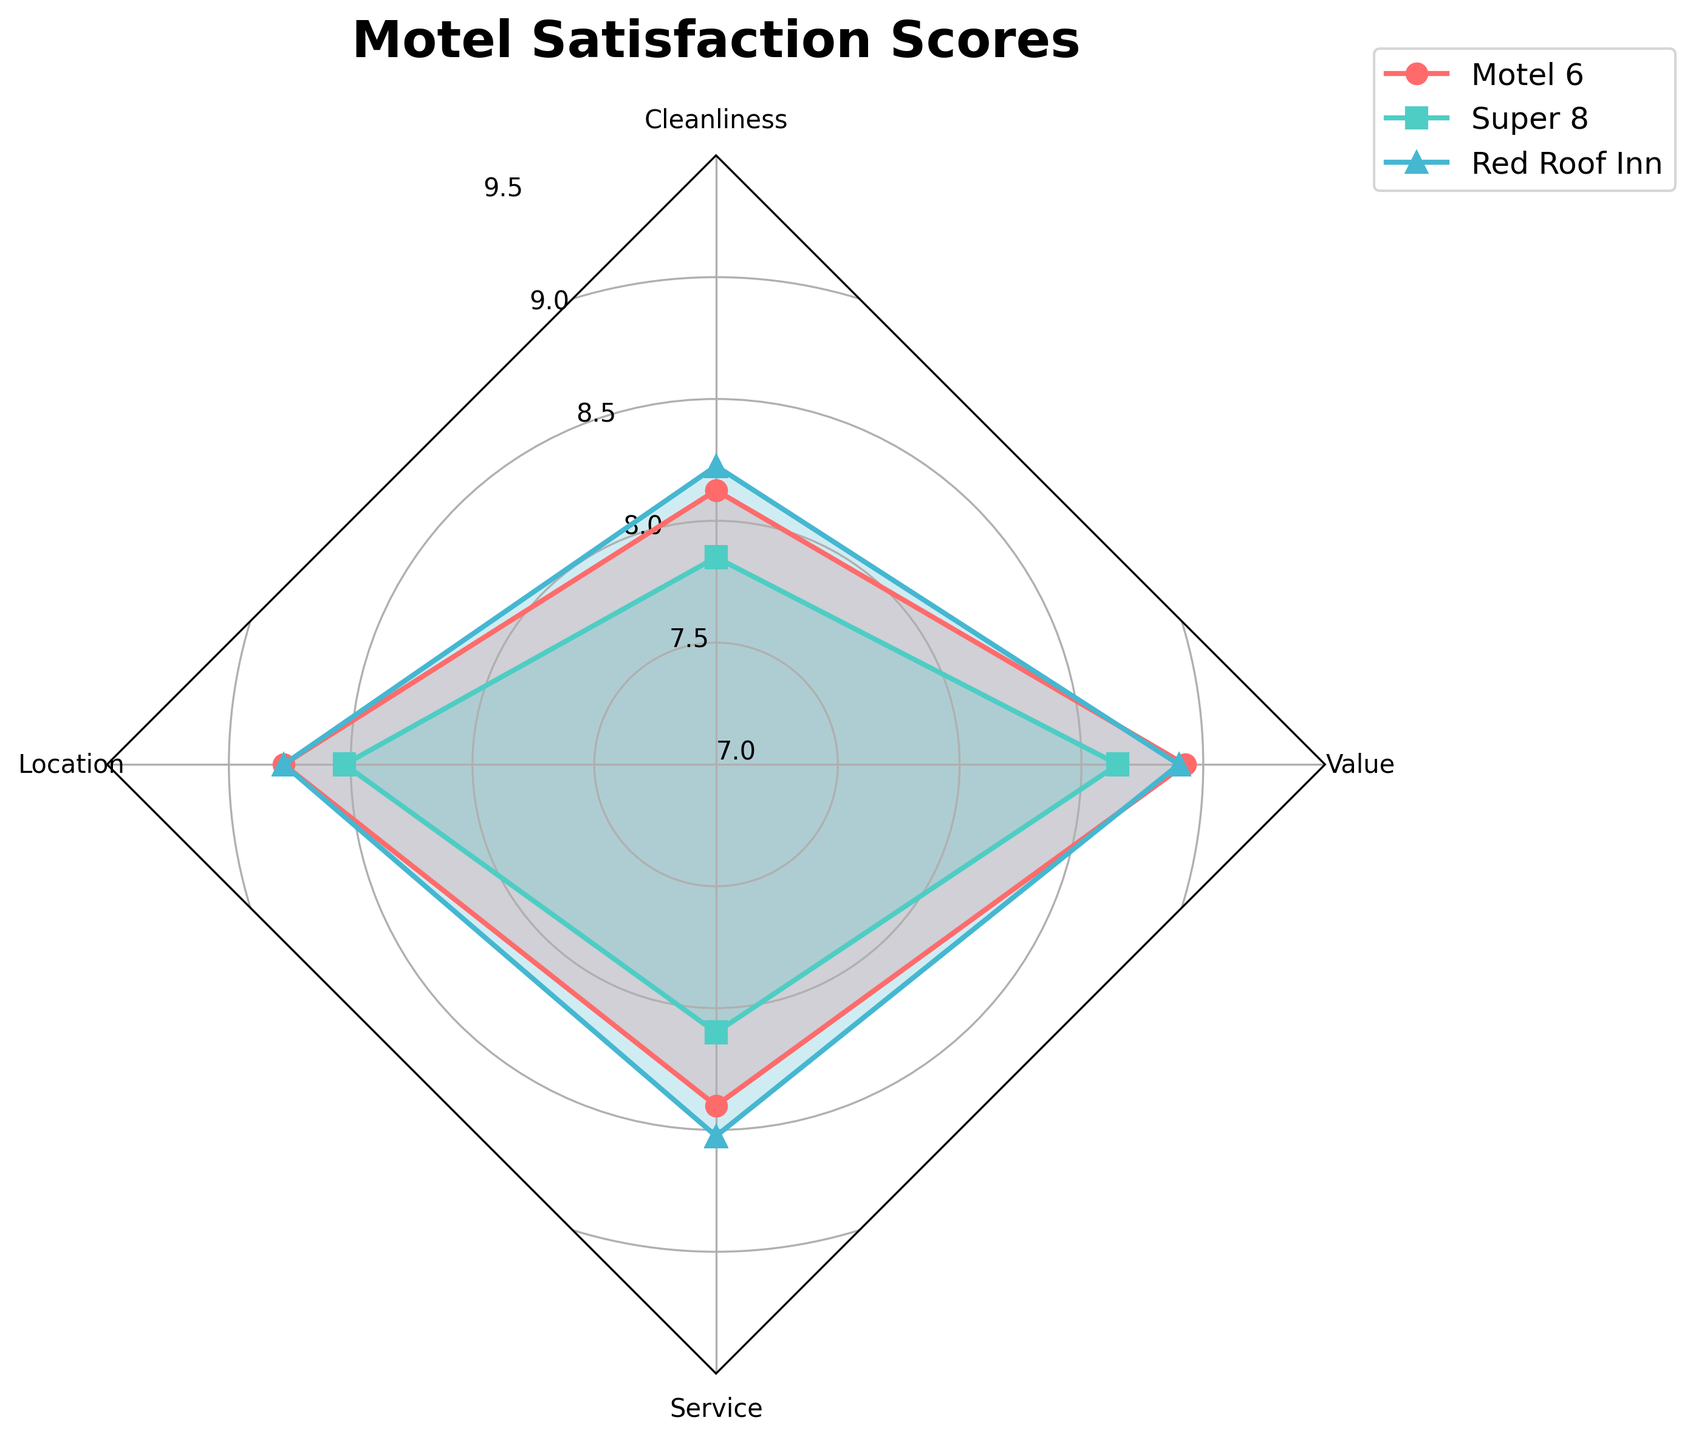which Motel has the highest average satisfaction score for Business travelers? The average satisfaction score for Business travelers for each motel is calculated from the data points: Motel 6 (7.8+8.2+8.0+8.5), Super 8 (7.5+8.0+7.7+8.2), Red Roof Inn (7.9+8.3+8.1+8.6). The highest average will be identified.
Answer: Red Roof Inn Which category does Motel 6 score the highest for Road Trip purposes? For Road Trip purposes, check the scores of Motel 6 in each category: Cleanliness (8.7), Location (8.9), Service (9.1), Value (9.0). The highest score is in Service.
Answer: Service Are the satisfaction scores for Super 8 in Cleanliness and Location during Leisure travel significantly different? Compare the scores for Cleanliness (8.3) and Location (8.4) for Super 8 during Leisure travel. Since the difference is minimal (0.1), they are not significantly different.
Answer: No How do the average value scores for each motel compare? Calculate the average value scores: Motel 6 (8.5+8.9+8.7+9.0), Super 8 (8.2+8.8+8.4+8.9), Red Roof Inn (8.6+9.0+8.8+9.1). Compare these averages.
Answer: Red Roof Inn > Motel 6 > Super 8 Which Motel has the most similar satisfaction scores across all travel purposes for Location? Compare the variation in scores for Location across travel purposes for each Motel: Motel 6 (8.2-8.9), Super 8 (8.0-8.6), Red Roof Inn (8.3-8.9). Motel 6 varies the least.
Answer: Motel 6 Which category shows the highest overall satisfaction score across all motels and travel purposes? Gather the highest scores in each category and find the maximum: Cleanliness (8.7), Location (8.9), Service (9.1), Value (9.1). The highest score is in Service and Value categories with 9.1.
Answer: Service and Value What is the range of Service scores for Red Roof Inn? Look at the Service scores for Red Roof Inn across all travel purposes: 8.1, 8.9, 8.6, 9.0. The maximum is 9.0 and the minimum is 8.1. The range is 9.0 - 8.1.
Answer: 0.9 Is there any category in which Super 8 always scores lower than Red Roof Inn? Compare Super 8 and Red Roof Inn scores in each category: Cleanliness, Location, Service, Value. Super 8 scores are lower in each comparison.
Answer: Yes 